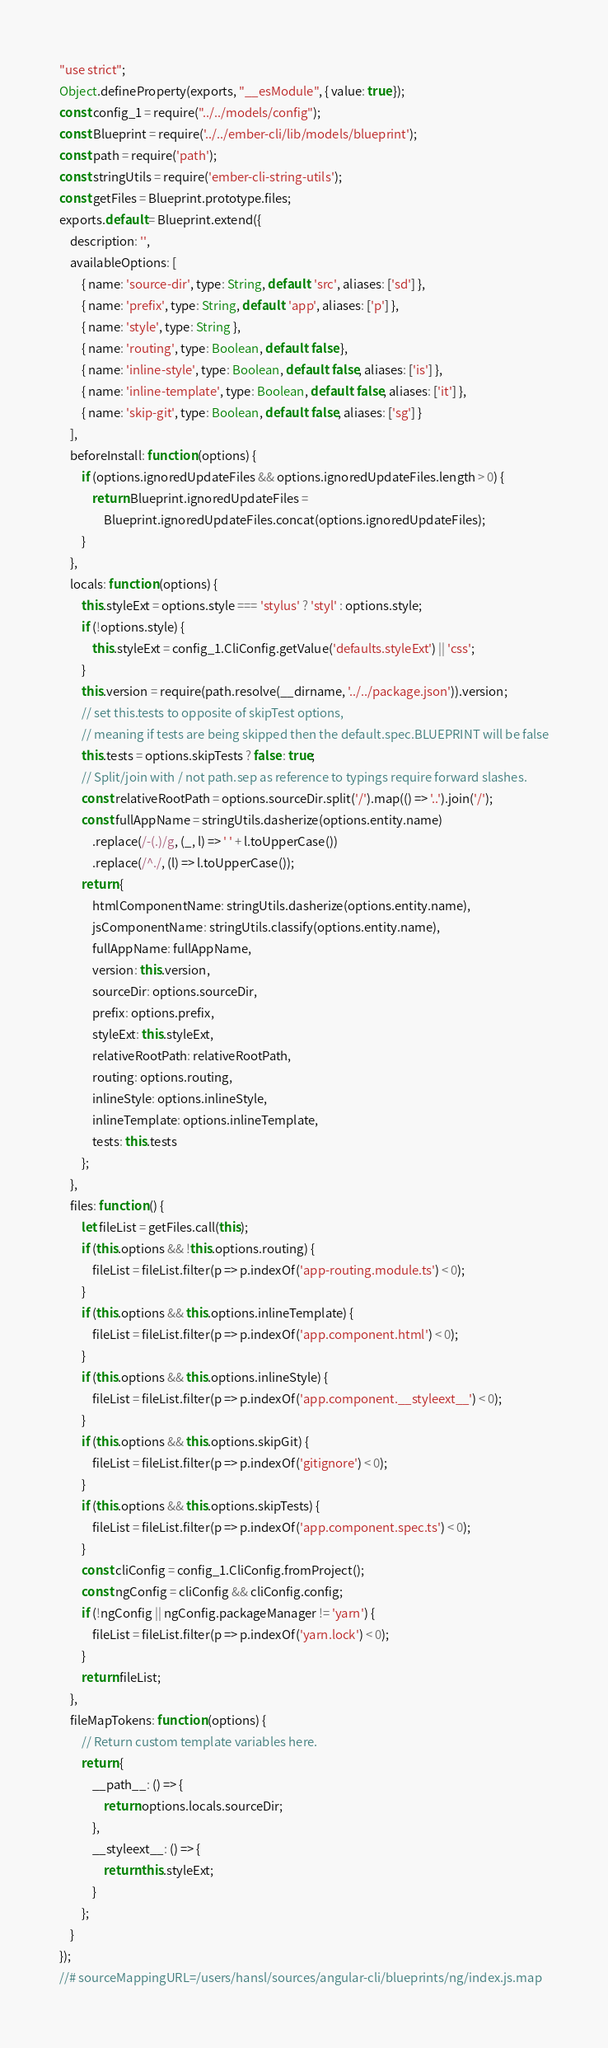<code> <loc_0><loc_0><loc_500><loc_500><_JavaScript_>"use strict";
Object.defineProperty(exports, "__esModule", { value: true });
const config_1 = require("../../models/config");
const Blueprint = require('../../ember-cli/lib/models/blueprint');
const path = require('path');
const stringUtils = require('ember-cli-string-utils');
const getFiles = Blueprint.prototype.files;
exports.default = Blueprint.extend({
    description: '',
    availableOptions: [
        { name: 'source-dir', type: String, default: 'src', aliases: ['sd'] },
        { name: 'prefix', type: String, default: 'app', aliases: ['p'] },
        { name: 'style', type: String },
        { name: 'routing', type: Boolean, default: false },
        { name: 'inline-style', type: Boolean, default: false, aliases: ['is'] },
        { name: 'inline-template', type: Boolean, default: false, aliases: ['it'] },
        { name: 'skip-git', type: Boolean, default: false, aliases: ['sg'] }
    ],
    beforeInstall: function (options) {
        if (options.ignoredUpdateFiles && options.ignoredUpdateFiles.length > 0) {
            return Blueprint.ignoredUpdateFiles =
                Blueprint.ignoredUpdateFiles.concat(options.ignoredUpdateFiles);
        }
    },
    locals: function (options) {
        this.styleExt = options.style === 'stylus' ? 'styl' : options.style;
        if (!options.style) {
            this.styleExt = config_1.CliConfig.getValue('defaults.styleExt') || 'css';
        }
        this.version = require(path.resolve(__dirname, '../../package.json')).version;
        // set this.tests to opposite of skipTest options,
        // meaning if tests are being skipped then the default.spec.BLUEPRINT will be false
        this.tests = options.skipTests ? false : true;
        // Split/join with / not path.sep as reference to typings require forward slashes.
        const relativeRootPath = options.sourceDir.split('/').map(() => '..').join('/');
        const fullAppName = stringUtils.dasherize(options.entity.name)
            .replace(/-(.)/g, (_, l) => ' ' + l.toUpperCase())
            .replace(/^./, (l) => l.toUpperCase());
        return {
            htmlComponentName: stringUtils.dasherize(options.entity.name),
            jsComponentName: stringUtils.classify(options.entity.name),
            fullAppName: fullAppName,
            version: this.version,
            sourceDir: options.sourceDir,
            prefix: options.prefix,
            styleExt: this.styleExt,
            relativeRootPath: relativeRootPath,
            routing: options.routing,
            inlineStyle: options.inlineStyle,
            inlineTemplate: options.inlineTemplate,
            tests: this.tests
        };
    },
    files: function () {
        let fileList = getFiles.call(this);
        if (this.options && !this.options.routing) {
            fileList = fileList.filter(p => p.indexOf('app-routing.module.ts') < 0);
        }
        if (this.options && this.options.inlineTemplate) {
            fileList = fileList.filter(p => p.indexOf('app.component.html') < 0);
        }
        if (this.options && this.options.inlineStyle) {
            fileList = fileList.filter(p => p.indexOf('app.component.__styleext__') < 0);
        }
        if (this.options && this.options.skipGit) {
            fileList = fileList.filter(p => p.indexOf('gitignore') < 0);
        }
        if (this.options && this.options.skipTests) {
            fileList = fileList.filter(p => p.indexOf('app.component.spec.ts') < 0);
        }
        const cliConfig = config_1.CliConfig.fromProject();
        const ngConfig = cliConfig && cliConfig.config;
        if (!ngConfig || ngConfig.packageManager != 'yarn') {
            fileList = fileList.filter(p => p.indexOf('yarn.lock') < 0);
        }
        return fileList;
    },
    fileMapTokens: function (options) {
        // Return custom template variables here.
        return {
            __path__: () => {
                return options.locals.sourceDir;
            },
            __styleext__: () => {
                return this.styleExt;
            }
        };
    }
});
//# sourceMappingURL=/users/hansl/sources/angular-cli/blueprints/ng/index.js.map</code> 